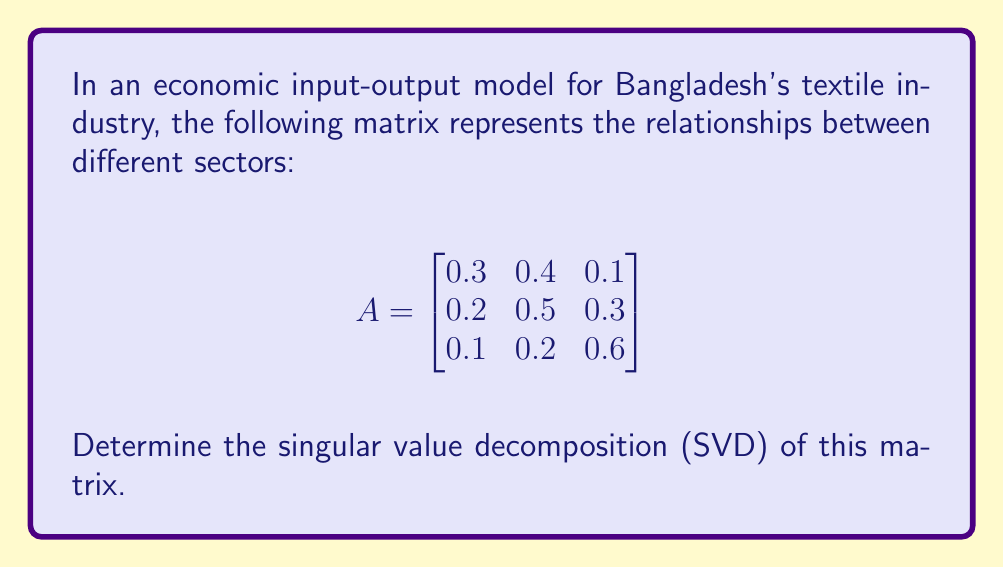Can you solve this math problem? To find the singular value decomposition of matrix A, we need to follow these steps:

1. Calculate $A^TA$ and $AA^T$:

$$A^TA = \begin{bmatrix}
0.14 & 0.31 & 0.23 \\
0.31 & 0.45 & 0.29 \\
0.23 & 0.29 & 0.46
\end{bmatrix}$$

$$AA^T = \begin{bmatrix}
0.26 & 0.35 & 0.19 \\
0.35 & 0.38 & 0.31 \\
0.19 & 0.31 & 0.41
\end{bmatrix}$$

2. Find the eigenvalues of $A^TA$ (which are the same as the squared singular values):

Solving $\det(A^TA - \lambda I) = 0$, we get:
$\lambda_1 \approx 0.9397$, $\lambda_2 \approx 0.0997$, $\lambda_3 \approx 0.0106$

3. Calculate the singular values:

$\sigma_1 = \sqrt{0.9397} \approx 0.9694$
$\sigma_2 = \sqrt{0.0997} \approx 0.3157$
$\sigma_3 = \sqrt{0.0106} \approx 0.1029$

4. Find the right singular vectors (eigenvectors of $A^TA$):

$v_1 \approx [0.5164, 0.6726, 0.5297]^T$
$v_2 \approx [-0.7733, 0.1078, 0.6247]^T$
$v_3 \approx [-0.3686, 0.7321, -0.5733]^T$

5. Find the left singular vectors:

$u_1 = \frac{1}{\sigma_1}Av_1 \approx [0.4600, 0.6104, 0.6446]^T$
$u_2 = \frac{1}{\sigma_2}Av_2 \approx [-0.8478, 0.3458, 0.4037]^T$
$u_3 = \frac{1}{\sigma_3}Av_3 \approx [-0.2646, 0.7120, -0.6494]^T$

6. Construct the SVD:

$A = U\Sigma V^T$

Where:
$U = [u_1 \quad u_2 \quad u_3]$
$\Sigma = \text{diag}(\sigma_1, \sigma_2, \sigma_3)$
$V = [v_1 \quad v_2 \quad v_3]$
Answer: $A = U\Sigma V^T$, where:

$U \approx \begin{bmatrix}
0.4600 & -0.8478 & -0.2646 \\
0.6104 & 0.3458 & 0.7120 \\
0.6446 & 0.4037 & -0.6494
\end{bmatrix}$

$\Sigma \approx \begin{bmatrix}
0.9694 & 0 & 0 \\
0 & 0.3157 & 0 \\
0 & 0 & 0.1029
\end{bmatrix}$

$V \approx \begin{bmatrix}
0.5164 & -0.7733 & -0.3686 \\
0.6726 & 0.1078 & 0.7321 \\
0.5297 & 0.6247 & -0.5733
\end{bmatrix}$ 